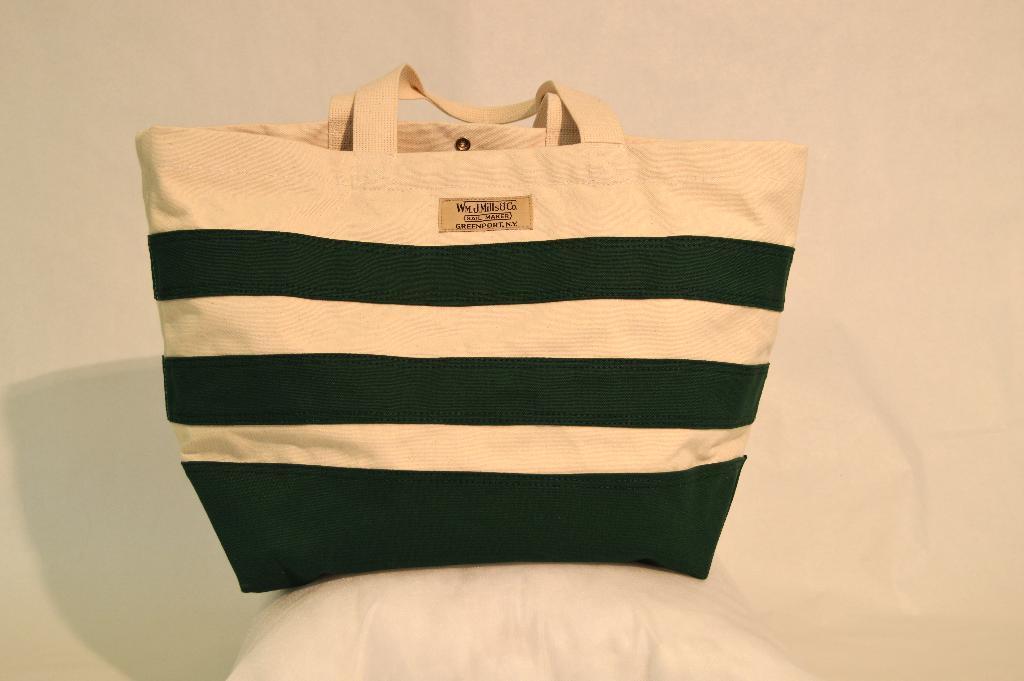How would you summarize this image in a sentence or two? In this image I can see a handbag. At the background it is in cream color. 